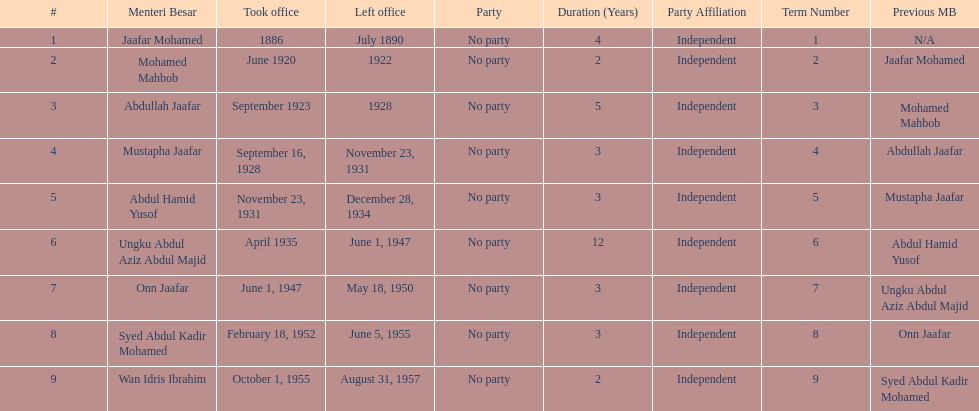What is the count of menteri besars during the pre-independence era? 9. 